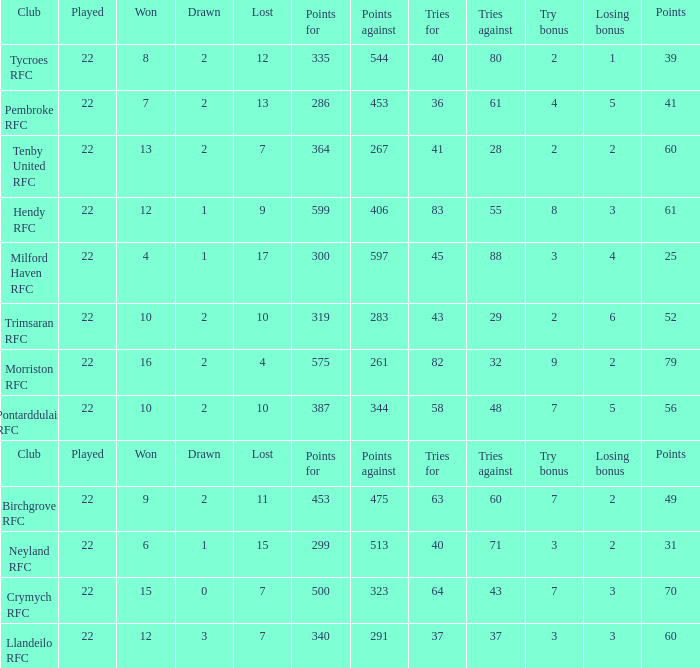What's the club with losing bonus being 1 Tycroes RFC. 